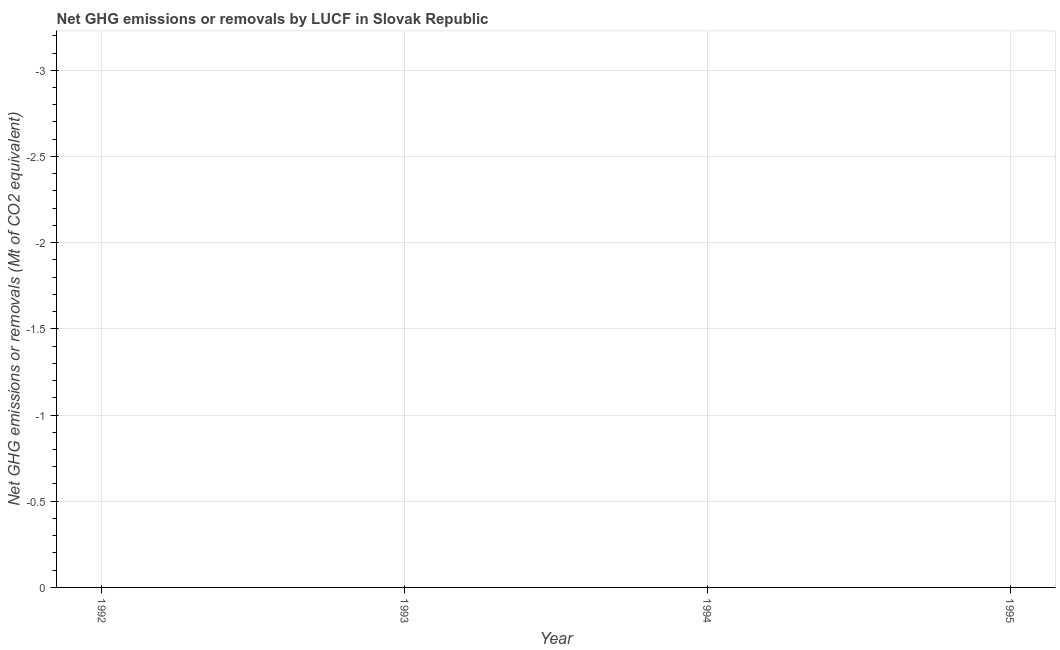What is the average ghg net emissions or removals per year?
Your response must be concise. 0. What is the median ghg net emissions or removals?
Keep it short and to the point. 0. In how many years, is the ghg net emissions or removals greater than -2.2 Mt?
Keep it short and to the point. 0. In how many years, is the ghg net emissions or removals greater than the average ghg net emissions or removals taken over all years?
Your answer should be compact. 0. Does the ghg net emissions or removals monotonically increase over the years?
Your response must be concise. Yes. How many dotlines are there?
Make the answer very short. 0. What is the difference between two consecutive major ticks on the Y-axis?
Ensure brevity in your answer.  0.5. Are the values on the major ticks of Y-axis written in scientific E-notation?
Your answer should be very brief. No. Does the graph contain any zero values?
Provide a short and direct response. Yes. Does the graph contain grids?
Make the answer very short. Yes. What is the title of the graph?
Your answer should be very brief. Net GHG emissions or removals by LUCF in Slovak Republic. What is the label or title of the Y-axis?
Your answer should be very brief. Net GHG emissions or removals (Mt of CO2 equivalent). 